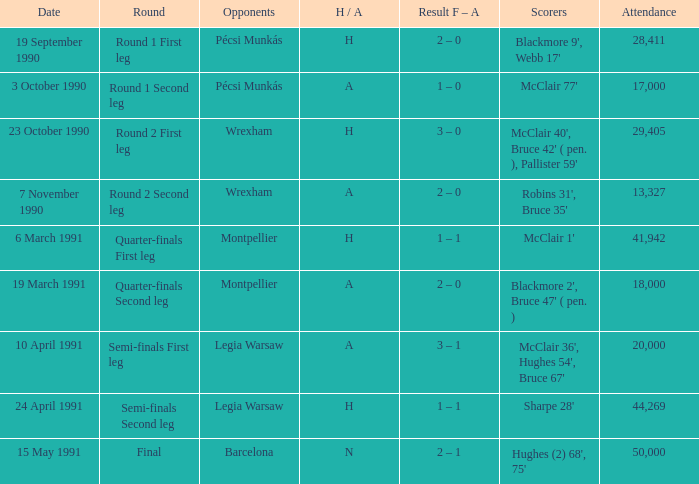What is the opponent name when the H/A is h with more than 28,411 in attendance and Sharpe 28' is the scorer? Legia Warsaw. 